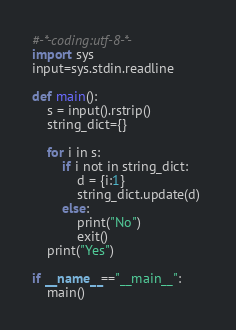Convert code to text. <code><loc_0><loc_0><loc_500><loc_500><_Python_>#-*-coding:utf-8-*-
import sys
input=sys.stdin.readline

def main():
    s = input().rstrip()
    string_dict={}

    for i in s:
        if i not in string_dict:
            d = {i:1}
            string_dict.update(d) 
        else:
            print("No")
            exit()
    print("Yes")

if __name__=="__main__":
    main()</code> 